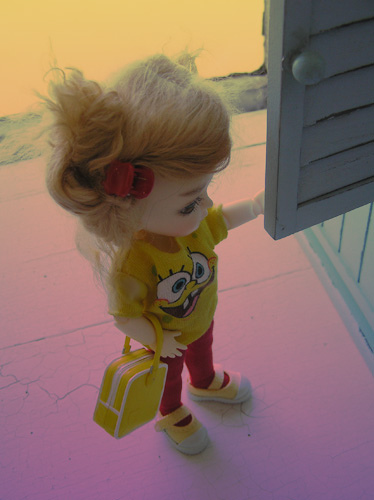<image>
Can you confirm if the child is on the countertop? No. The child is not positioned on the countertop. They may be near each other, but the child is not supported by or resting on top of the countertop. Is there a bag on the doll? No. The bag is not positioned on the doll. They may be near each other, but the bag is not supported by or resting on top of the doll. 